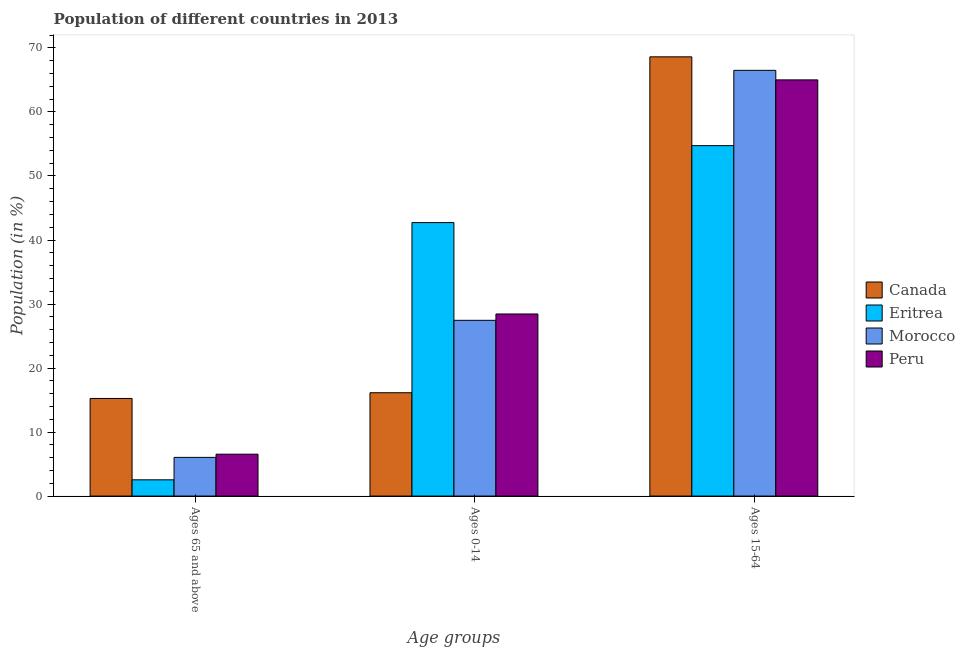How many groups of bars are there?
Provide a succinct answer. 3. Are the number of bars on each tick of the X-axis equal?
Your answer should be very brief. Yes. How many bars are there on the 1st tick from the right?
Your answer should be very brief. 4. What is the label of the 3rd group of bars from the left?
Your response must be concise. Ages 15-64. What is the percentage of population within the age-group 0-14 in Morocco?
Offer a terse response. 27.45. Across all countries, what is the maximum percentage of population within the age-group of 65 and above?
Provide a short and direct response. 15.25. Across all countries, what is the minimum percentage of population within the age-group 0-14?
Make the answer very short. 16.14. In which country was the percentage of population within the age-group 0-14 maximum?
Offer a terse response. Eritrea. In which country was the percentage of population within the age-group 15-64 minimum?
Your answer should be compact. Eritrea. What is the total percentage of population within the age-group 0-14 in the graph?
Make the answer very short. 114.76. What is the difference between the percentage of population within the age-group 15-64 in Morocco and that in Canada?
Give a very brief answer. -2.11. What is the difference between the percentage of population within the age-group 0-14 in Morocco and the percentage of population within the age-group of 65 and above in Eritrea?
Keep it short and to the point. 24.92. What is the average percentage of population within the age-group 15-64 per country?
Offer a very short reply. 63.72. What is the difference between the percentage of population within the age-group of 65 and above and percentage of population within the age-group 15-64 in Morocco?
Give a very brief answer. -60.46. What is the ratio of the percentage of population within the age-group 0-14 in Eritrea to that in Peru?
Make the answer very short. 1.5. Is the difference between the percentage of population within the age-group 0-14 in Peru and Eritrea greater than the difference between the percentage of population within the age-group of 65 and above in Peru and Eritrea?
Keep it short and to the point. No. What is the difference between the highest and the second highest percentage of population within the age-group 0-14?
Give a very brief answer. 14.28. What is the difference between the highest and the lowest percentage of population within the age-group of 65 and above?
Your answer should be compact. 12.71. What does the 3rd bar from the left in Ages 0-14 represents?
Your answer should be compact. Morocco. What does the 2nd bar from the right in Ages 0-14 represents?
Offer a terse response. Morocco. Is it the case that in every country, the sum of the percentage of population within the age-group of 65 and above and percentage of population within the age-group 0-14 is greater than the percentage of population within the age-group 15-64?
Your response must be concise. No. How many bars are there?
Your answer should be compact. 12. Where does the legend appear in the graph?
Offer a very short reply. Center right. How many legend labels are there?
Your response must be concise. 4. How are the legend labels stacked?
Your answer should be compact. Vertical. What is the title of the graph?
Provide a succinct answer. Population of different countries in 2013. Does "Morocco" appear as one of the legend labels in the graph?
Your answer should be very brief. Yes. What is the label or title of the X-axis?
Give a very brief answer. Age groups. What is the Population (in %) of Canada in Ages 65 and above?
Give a very brief answer. 15.25. What is the Population (in %) in Eritrea in Ages 65 and above?
Provide a short and direct response. 2.54. What is the Population (in %) in Morocco in Ages 65 and above?
Your response must be concise. 6.04. What is the Population (in %) in Peru in Ages 65 and above?
Keep it short and to the point. 6.54. What is the Population (in %) in Canada in Ages 0-14?
Your response must be concise. 16.14. What is the Population (in %) of Eritrea in Ages 0-14?
Give a very brief answer. 42.72. What is the Population (in %) of Morocco in Ages 0-14?
Keep it short and to the point. 27.45. What is the Population (in %) in Peru in Ages 0-14?
Make the answer very short. 28.44. What is the Population (in %) in Canada in Ages 15-64?
Keep it short and to the point. 68.61. What is the Population (in %) in Eritrea in Ages 15-64?
Make the answer very short. 54.74. What is the Population (in %) of Morocco in Ages 15-64?
Your answer should be very brief. 66.5. What is the Population (in %) of Peru in Ages 15-64?
Provide a succinct answer. 65.01. Across all Age groups, what is the maximum Population (in %) of Canada?
Your answer should be very brief. 68.61. Across all Age groups, what is the maximum Population (in %) in Eritrea?
Offer a terse response. 54.74. Across all Age groups, what is the maximum Population (in %) of Morocco?
Give a very brief answer. 66.5. Across all Age groups, what is the maximum Population (in %) of Peru?
Your response must be concise. 65.01. Across all Age groups, what is the minimum Population (in %) in Canada?
Offer a very short reply. 15.25. Across all Age groups, what is the minimum Population (in %) in Eritrea?
Keep it short and to the point. 2.54. Across all Age groups, what is the minimum Population (in %) in Morocco?
Your answer should be very brief. 6.04. Across all Age groups, what is the minimum Population (in %) in Peru?
Your answer should be very brief. 6.54. What is the difference between the Population (in %) of Canada in Ages 65 and above and that in Ages 0-14?
Your answer should be compact. -0.89. What is the difference between the Population (in %) in Eritrea in Ages 65 and above and that in Ages 0-14?
Offer a terse response. -40.18. What is the difference between the Population (in %) in Morocco in Ages 65 and above and that in Ages 0-14?
Give a very brief answer. -21.41. What is the difference between the Population (in %) of Peru in Ages 65 and above and that in Ages 0-14?
Ensure brevity in your answer.  -21.9. What is the difference between the Population (in %) in Canada in Ages 65 and above and that in Ages 15-64?
Offer a very short reply. -53.37. What is the difference between the Population (in %) in Eritrea in Ages 65 and above and that in Ages 15-64?
Your answer should be compact. -52.2. What is the difference between the Population (in %) in Morocco in Ages 65 and above and that in Ages 15-64?
Your response must be concise. -60.46. What is the difference between the Population (in %) of Peru in Ages 65 and above and that in Ages 15-64?
Your answer should be very brief. -58.47. What is the difference between the Population (in %) in Canada in Ages 0-14 and that in Ages 15-64?
Offer a terse response. -52.47. What is the difference between the Population (in %) of Eritrea in Ages 0-14 and that in Ages 15-64?
Provide a short and direct response. -12.02. What is the difference between the Population (in %) of Morocco in Ages 0-14 and that in Ages 15-64?
Provide a succinct answer. -39.05. What is the difference between the Population (in %) of Peru in Ages 0-14 and that in Ages 15-64?
Give a very brief answer. -36.57. What is the difference between the Population (in %) of Canada in Ages 65 and above and the Population (in %) of Eritrea in Ages 0-14?
Your response must be concise. -27.47. What is the difference between the Population (in %) in Canada in Ages 65 and above and the Population (in %) in Morocco in Ages 0-14?
Your response must be concise. -12.21. What is the difference between the Population (in %) in Canada in Ages 65 and above and the Population (in %) in Peru in Ages 0-14?
Ensure brevity in your answer.  -13.2. What is the difference between the Population (in %) of Eritrea in Ages 65 and above and the Population (in %) of Morocco in Ages 0-14?
Offer a very short reply. -24.92. What is the difference between the Population (in %) of Eritrea in Ages 65 and above and the Population (in %) of Peru in Ages 0-14?
Give a very brief answer. -25.91. What is the difference between the Population (in %) in Morocco in Ages 65 and above and the Population (in %) in Peru in Ages 0-14?
Your response must be concise. -22.4. What is the difference between the Population (in %) in Canada in Ages 65 and above and the Population (in %) in Eritrea in Ages 15-64?
Your answer should be very brief. -39.49. What is the difference between the Population (in %) of Canada in Ages 65 and above and the Population (in %) of Morocco in Ages 15-64?
Provide a succinct answer. -51.26. What is the difference between the Population (in %) in Canada in Ages 65 and above and the Population (in %) in Peru in Ages 15-64?
Your answer should be compact. -49.77. What is the difference between the Population (in %) of Eritrea in Ages 65 and above and the Population (in %) of Morocco in Ages 15-64?
Offer a very short reply. -63.97. What is the difference between the Population (in %) in Eritrea in Ages 65 and above and the Population (in %) in Peru in Ages 15-64?
Provide a succinct answer. -62.47. What is the difference between the Population (in %) in Morocco in Ages 65 and above and the Population (in %) in Peru in Ages 15-64?
Offer a very short reply. -58.97. What is the difference between the Population (in %) of Canada in Ages 0-14 and the Population (in %) of Eritrea in Ages 15-64?
Your answer should be very brief. -38.6. What is the difference between the Population (in %) of Canada in Ages 0-14 and the Population (in %) of Morocco in Ages 15-64?
Provide a succinct answer. -50.36. What is the difference between the Population (in %) in Canada in Ages 0-14 and the Population (in %) in Peru in Ages 15-64?
Keep it short and to the point. -48.87. What is the difference between the Population (in %) in Eritrea in Ages 0-14 and the Population (in %) in Morocco in Ages 15-64?
Your answer should be very brief. -23.78. What is the difference between the Population (in %) of Eritrea in Ages 0-14 and the Population (in %) of Peru in Ages 15-64?
Offer a terse response. -22.29. What is the difference between the Population (in %) in Morocco in Ages 0-14 and the Population (in %) in Peru in Ages 15-64?
Your answer should be very brief. -37.56. What is the average Population (in %) of Canada per Age groups?
Give a very brief answer. 33.33. What is the average Population (in %) in Eritrea per Age groups?
Provide a short and direct response. 33.33. What is the average Population (in %) in Morocco per Age groups?
Ensure brevity in your answer.  33.33. What is the average Population (in %) of Peru per Age groups?
Your response must be concise. 33.33. What is the difference between the Population (in %) in Canada and Population (in %) in Eritrea in Ages 65 and above?
Keep it short and to the point. 12.71. What is the difference between the Population (in %) in Canada and Population (in %) in Morocco in Ages 65 and above?
Provide a short and direct response. 9.2. What is the difference between the Population (in %) in Canada and Population (in %) in Peru in Ages 65 and above?
Provide a short and direct response. 8.7. What is the difference between the Population (in %) of Eritrea and Population (in %) of Morocco in Ages 65 and above?
Keep it short and to the point. -3.5. What is the difference between the Population (in %) in Eritrea and Population (in %) in Peru in Ages 65 and above?
Your response must be concise. -4. What is the difference between the Population (in %) of Morocco and Population (in %) of Peru in Ages 65 and above?
Give a very brief answer. -0.5. What is the difference between the Population (in %) in Canada and Population (in %) in Eritrea in Ages 0-14?
Your response must be concise. -26.58. What is the difference between the Population (in %) of Canada and Population (in %) of Morocco in Ages 0-14?
Offer a terse response. -11.31. What is the difference between the Population (in %) in Canada and Population (in %) in Peru in Ages 0-14?
Make the answer very short. -12.3. What is the difference between the Population (in %) of Eritrea and Population (in %) of Morocco in Ages 0-14?
Your answer should be very brief. 15.27. What is the difference between the Population (in %) of Eritrea and Population (in %) of Peru in Ages 0-14?
Offer a very short reply. 14.28. What is the difference between the Population (in %) of Morocco and Population (in %) of Peru in Ages 0-14?
Provide a short and direct response. -0.99. What is the difference between the Population (in %) in Canada and Population (in %) in Eritrea in Ages 15-64?
Your answer should be compact. 13.87. What is the difference between the Population (in %) in Canada and Population (in %) in Morocco in Ages 15-64?
Give a very brief answer. 2.11. What is the difference between the Population (in %) in Canada and Population (in %) in Peru in Ages 15-64?
Your answer should be very brief. 3.6. What is the difference between the Population (in %) in Eritrea and Population (in %) in Morocco in Ages 15-64?
Offer a terse response. -11.76. What is the difference between the Population (in %) of Eritrea and Population (in %) of Peru in Ages 15-64?
Provide a succinct answer. -10.27. What is the difference between the Population (in %) of Morocco and Population (in %) of Peru in Ages 15-64?
Provide a succinct answer. 1.49. What is the ratio of the Population (in %) of Canada in Ages 65 and above to that in Ages 0-14?
Give a very brief answer. 0.94. What is the ratio of the Population (in %) in Eritrea in Ages 65 and above to that in Ages 0-14?
Make the answer very short. 0.06. What is the ratio of the Population (in %) of Morocco in Ages 65 and above to that in Ages 0-14?
Ensure brevity in your answer.  0.22. What is the ratio of the Population (in %) in Peru in Ages 65 and above to that in Ages 0-14?
Keep it short and to the point. 0.23. What is the ratio of the Population (in %) of Canada in Ages 65 and above to that in Ages 15-64?
Make the answer very short. 0.22. What is the ratio of the Population (in %) of Eritrea in Ages 65 and above to that in Ages 15-64?
Your response must be concise. 0.05. What is the ratio of the Population (in %) in Morocco in Ages 65 and above to that in Ages 15-64?
Your answer should be compact. 0.09. What is the ratio of the Population (in %) in Peru in Ages 65 and above to that in Ages 15-64?
Provide a succinct answer. 0.1. What is the ratio of the Population (in %) of Canada in Ages 0-14 to that in Ages 15-64?
Provide a succinct answer. 0.24. What is the ratio of the Population (in %) of Eritrea in Ages 0-14 to that in Ages 15-64?
Your answer should be very brief. 0.78. What is the ratio of the Population (in %) of Morocco in Ages 0-14 to that in Ages 15-64?
Ensure brevity in your answer.  0.41. What is the ratio of the Population (in %) in Peru in Ages 0-14 to that in Ages 15-64?
Offer a very short reply. 0.44. What is the difference between the highest and the second highest Population (in %) in Canada?
Keep it short and to the point. 52.47. What is the difference between the highest and the second highest Population (in %) of Eritrea?
Make the answer very short. 12.02. What is the difference between the highest and the second highest Population (in %) of Morocco?
Give a very brief answer. 39.05. What is the difference between the highest and the second highest Population (in %) in Peru?
Keep it short and to the point. 36.57. What is the difference between the highest and the lowest Population (in %) of Canada?
Ensure brevity in your answer.  53.37. What is the difference between the highest and the lowest Population (in %) in Eritrea?
Your response must be concise. 52.2. What is the difference between the highest and the lowest Population (in %) of Morocco?
Provide a succinct answer. 60.46. What is the difference between the highest and the lowest Population (in %) of Peru?
Ensure brevity in your answer.  58.47. 